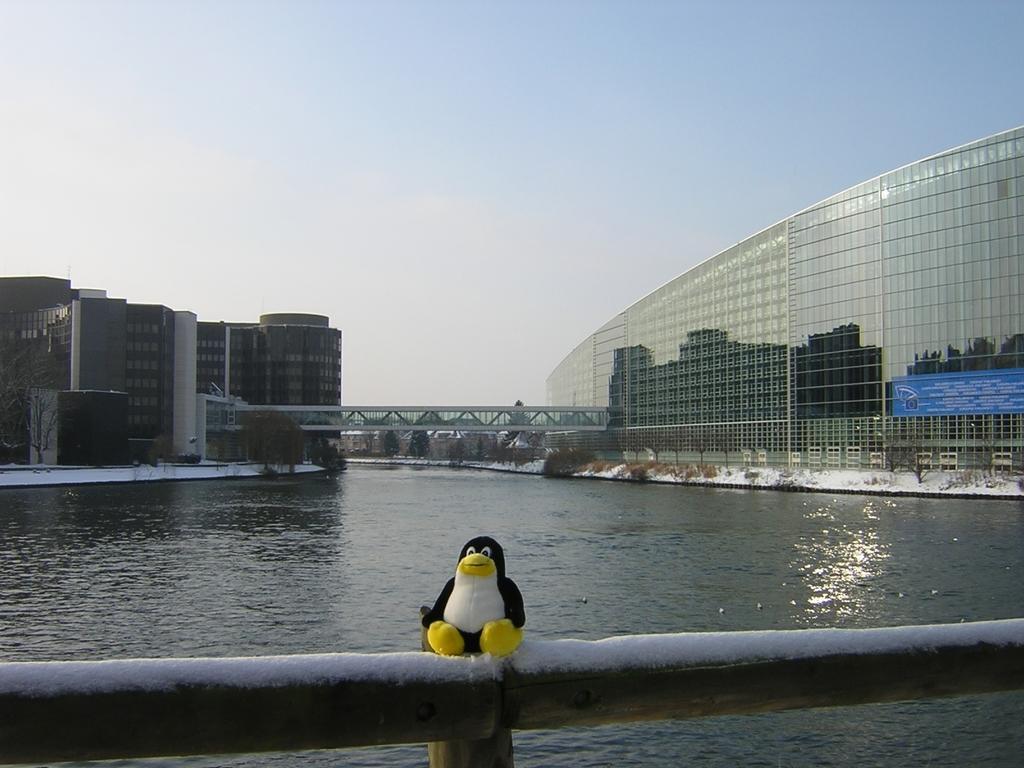Describe this image in one or two sentences. In this image there is a railing. There is a toy on the railing. Behind the railing there is the water. In the background there are buildings and trees. In the center there is a bridge. At the top there is the sky. To the right there is a board with text on a building. 